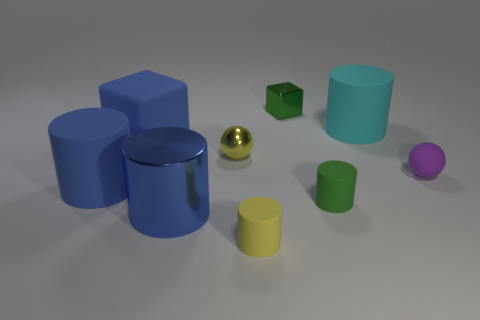There is a big matte cylinder that is left of the small yellow matte object; is it the same color as the tiny shiny sphere that is to the right of the blue matte block?
Your response must be concise. No. What number of large blue shiny objects are to the right of the large blue cylinder that is to the right of the rubber cylinder that is to the left of the blue shiny object?
Provide a short and direct response. 0. What number of small objects are both behind the big blue metallic cylinder and on the left side of the big cyan cylinder?
Offer a terse response. 3. Are there more tiny blocks that are to the left of the tiny metal sphere than cylinders?
Your answer should be very brief. No. What number of yellow shiny objects are the same size as the cyan matte object?
Your answer should be very brief. 0. The object that is the same color as the tiny shiny sphere is what size?
Provide a succinct answer. Small. How many big objects are either green rubber blocks or green cylinders?
Offer a very short reply. 0. What number of cyan rubber cylinders are there?
Provide a succinct answer. 1. Is the number of big metallic cylinders that are to the right of the cyan cylinder the same as the number of small rubber objects that are behind the large blue metallic cylinder?
Offer a very short reply. No. There is a purple thing; are there any small green blocks in front of it?
Keep it short and to the point. No. 